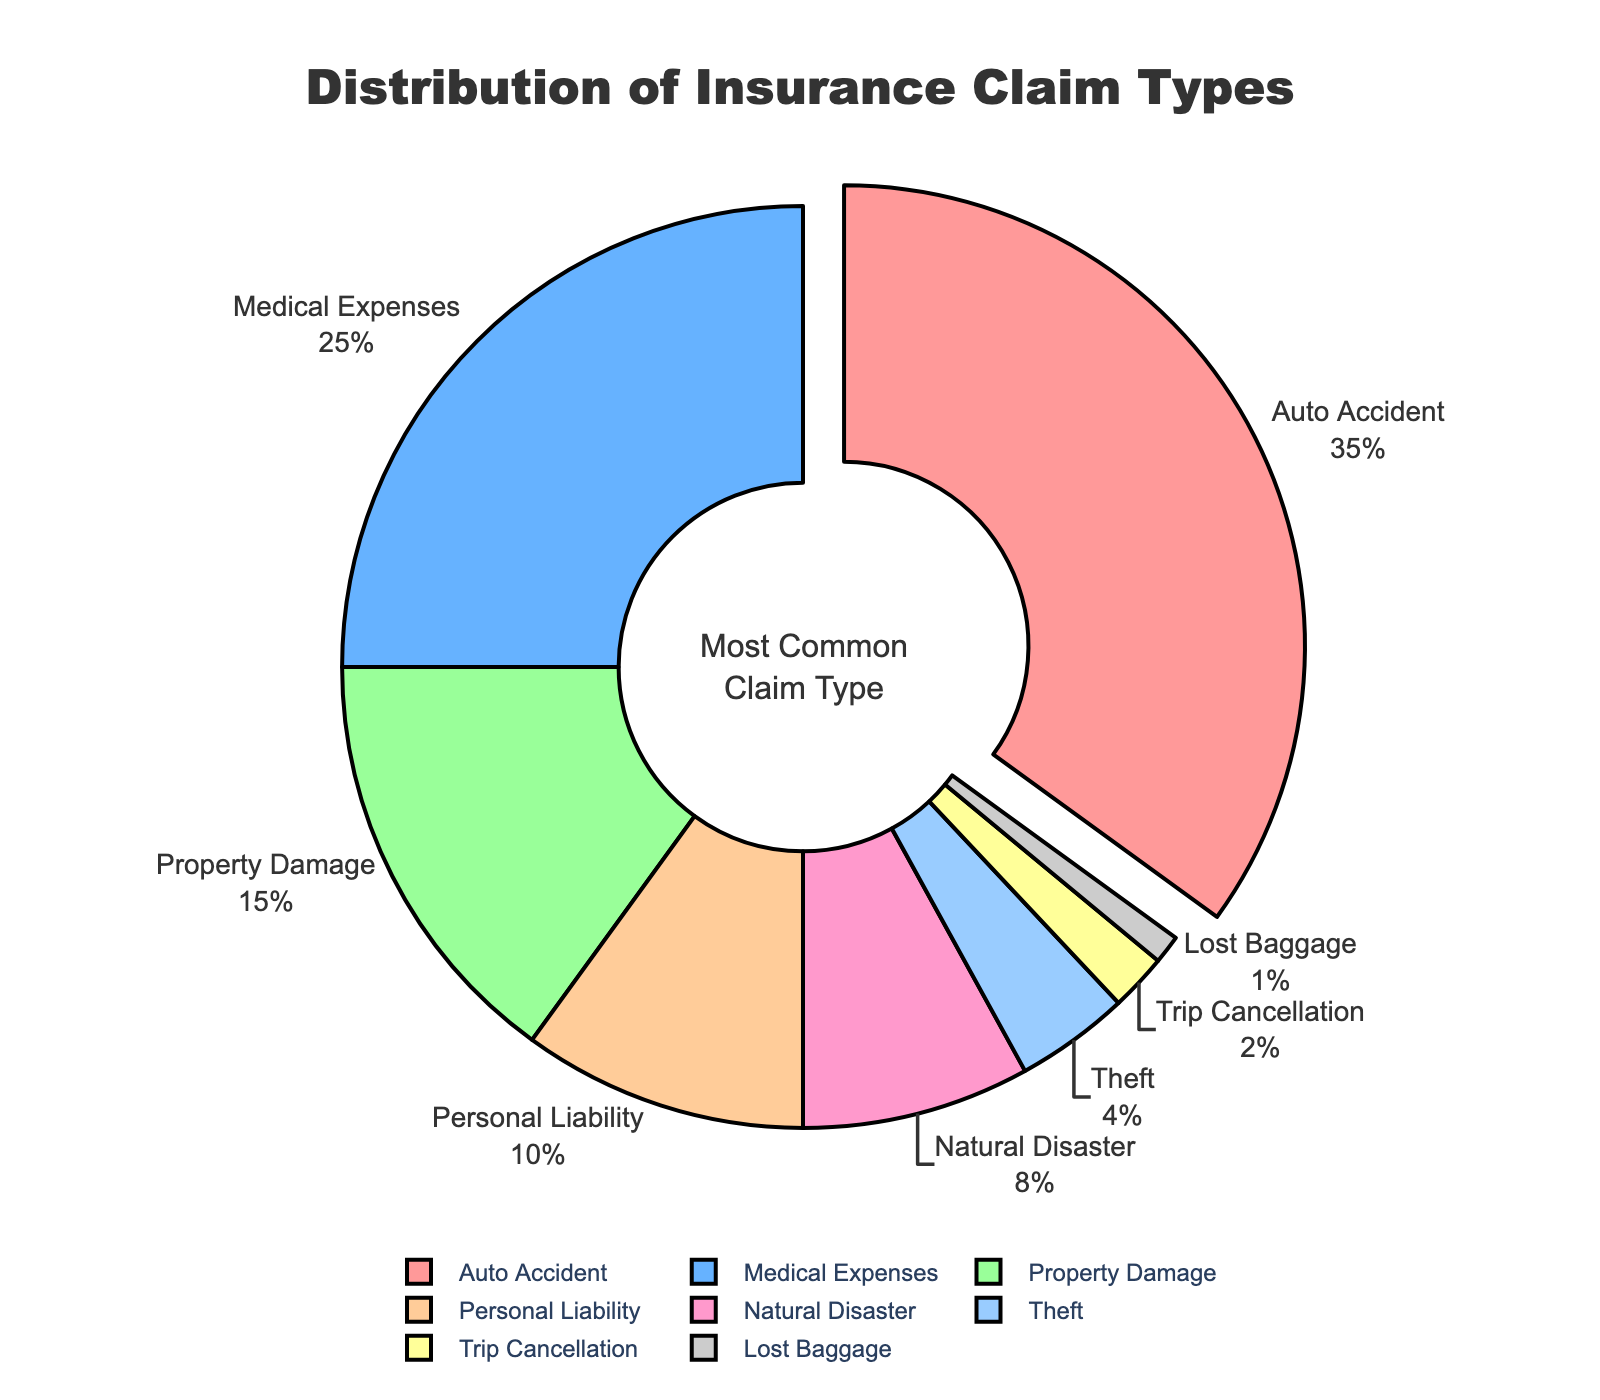What is the most common claim type? The pie chart shows that the segment representing "Auto Accident" is the largest with 35%. Additionally, it is also highlighted in the chart with a slight pull-out effect.
Answer: Auto Accident How much more common are auto accident claims compared to medical expenses claims? The percentage for auto accident claims is 35% and for medical expenses, it's 25%. The difference between these two percentages is 35% - 25% = 10%.
Answer: 10% What is the total percentage of all types of claims that are less common than personal liability claims? Personal liability claims are 10%. The less common claim types are natural disaster (8%), theft (4%), trip cancellation (2%), and lost baggage (1%). Summing these percentages: 8% + 4% + 2% + 1% = 15%.
Answer: 15% Which claim type has the lowest percentage? By looking at the pie chart, the smallest segment, representing 1%, corresponds to "Lost Baggage".
Answer: Lost Baggage How do property damage claims compare to personal liability claims? In the pie chart, property damage is 15% and personal liability is 10%. Therefore, property damage claims are more common than personal liability claims.
Answer: Property Damage is more common than Personal Liability What is the combined percentage of claim types that exceed 10%? The claim types exceeding 10% are auto accident (35%), medical expenses (25%), and property damage (15%). Summing these percentages: 35% + 25% + 15% = 75%.
Answer: 75% What claim types are depicted in shades of blue? Upon examining the pie chart, the claim types in shades of blue are "Medical Expenses" and "Theft".
Answer: Medical Expenses and Theft How many claim types have a percentage lower than natural disaster claims? Natural disaster claims are 8%. The claim types with lower percentages are theft (4%), trip cancellation (2%), and lost baggage (1%). This makes a total of three claim types.
Answer: 3 What is the average percentage of auto accident, medical expenses, and property damage claims? The percentages for these claim types are 35%, 25%, and 15%. Adding these gives us 75%. Dividing by the number of these claim types (3): 75% / 3 = 25%.
Answer: 25% 